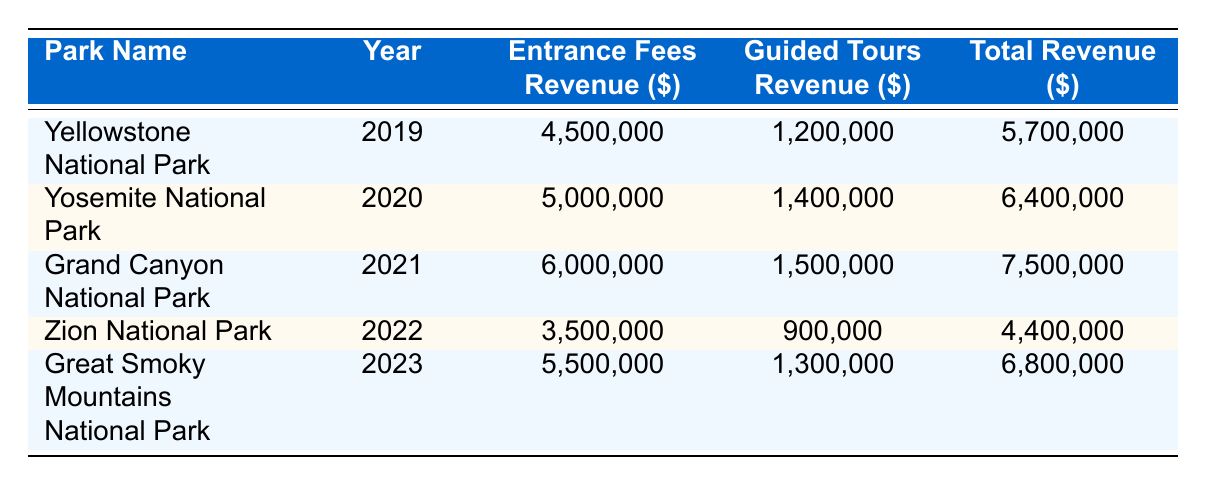What was the total revenue for Grand Canyon National Park in 2021? The table states that the total revenue for Grand Canyon National Park in 2021 is 7,500,000.
Answer: 7,500,000 Which park generated the highest entrance fees revenue in 2023? The table shows that Great Smoky Mountains National Park had the highest entrance fees revenue in 2023, amounting to 5,500,000.
Answer: Great Smoky Mountains National Park What is the difference between the entrance fees revenue of Grand Canyon National Park in 2021 and Zion National Park in 2022? The entrance fees revenue for Grand Canyon National Park in 2021 is 6,000,000, while for Zion National Park in 2022 it is 3,500,000. The difference is 6,000,000 - 3,500,000 = 2,500,000.
Answer: 2,500,000 Did Yosemite National Park have a higher total revenue than Zion National Park in 2022? The total revenue for Yosemite National Park in 2020 is 6,400,000, while the total revenue for Zion National Park in 2022 is 4,400,000. Since 6,400,000 is greater than 4,400,000, the statement is true.
Answer: Yes What was the average entrance fees revenue across all parks from 2019 to 2023? The entrance fees revenue for the years is: 4,500,000 (2019), 5,000,000 (2020), 6,000,000 (2021), 3,500,000 (2022), and 5,500,000 (2023). To find the average, first sum these amounts: 4,500,000 + 5,000,000 + 6,000,000 + 3,500,000 + 5,500,000 = 24,500,000. Then divide by 5, yielding an average of 24,500,000 / 5 = 4,900,000.
Answer: 4,900,000 